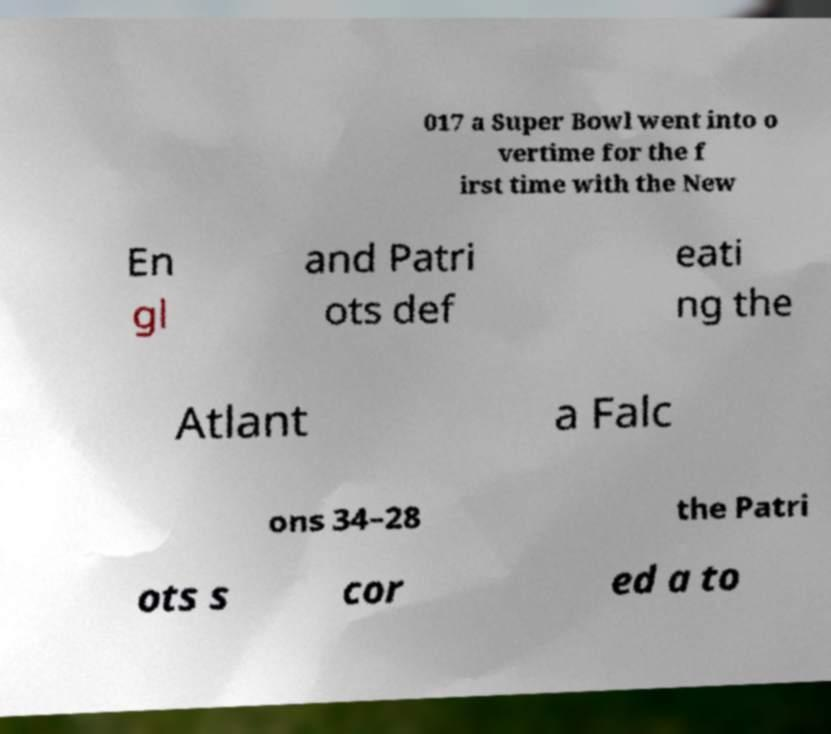Can you accurately transcribe the text from the provided image for me? 017 a Super Bowl went into o vertime for the f irst time with the New En gl and Patri ots def eati ng the Atlant a Falc ons 34–28 the Patri ots s cor ed a to 